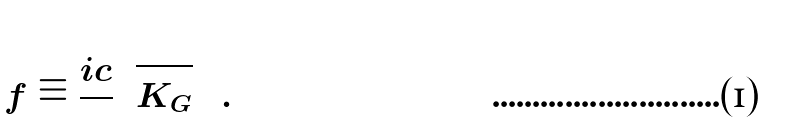Convert formula to latex. <formula><loc_0><loc_0><loc_500><loc_500>\left ( f \equiv \frac { i c } { } \sqrt { K _ { G } } \right ) .</formula> 